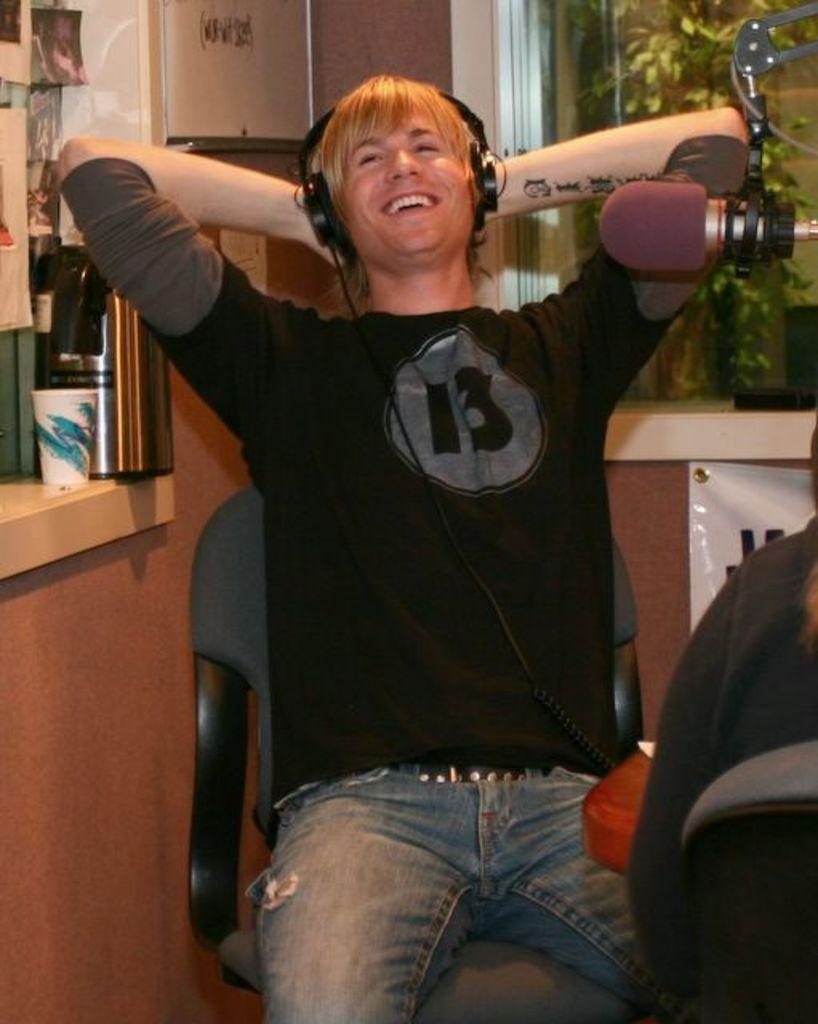What is the man in the image doing? The man is sitting on a chair in the image. What is the man's facial expression? The man has a smile on his face. What equipment is visible in the image? There is a microphone (mic) and a headphone in the image. How many pigs are visible in the image? There are no pigs present in the image. What shape is the balloon in the image? There is no balloon present in the image. 